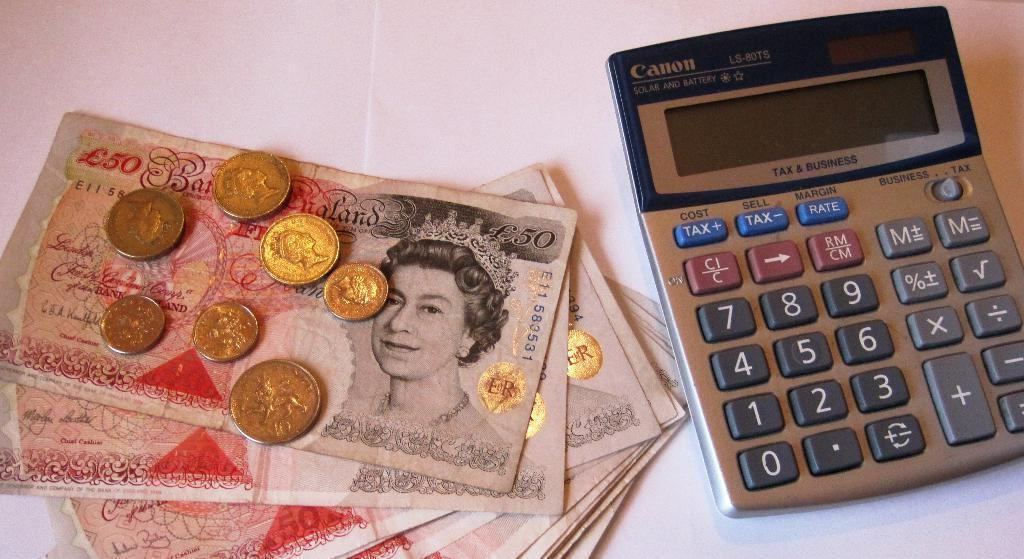<image>
Offer a succinct explanation of the picture presented. Foreign coins and bills sit next to a Canon calculator. 